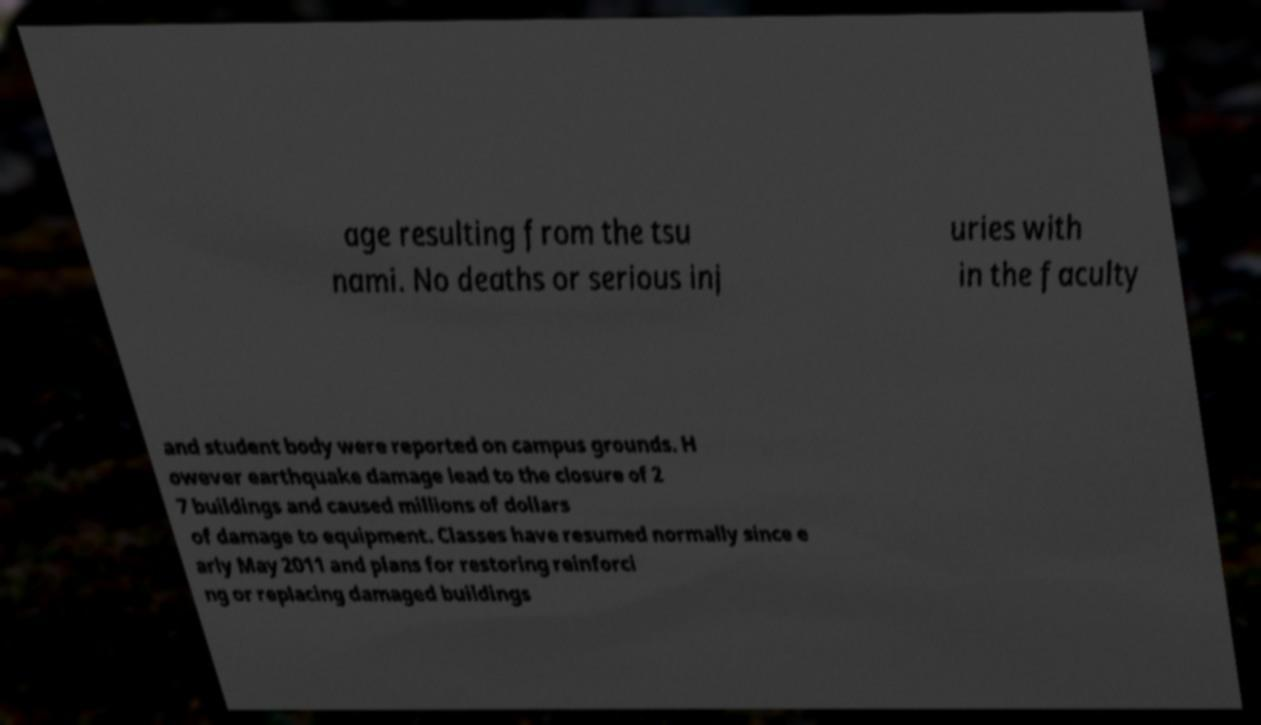I need the written content from this picture converted into text. Can you do that? age resulting from the tsu nami. No deaths or serious inj uries with in the faculty and student body were reported on campus grounds. H owever earthquake damage lead to the closure of 2 7 buildings and caused millions of dollars of damage to equipment. Classes have resumed normally since e arly May 2011 and plans for restoring reinforci ng or replacing damaged buildings 